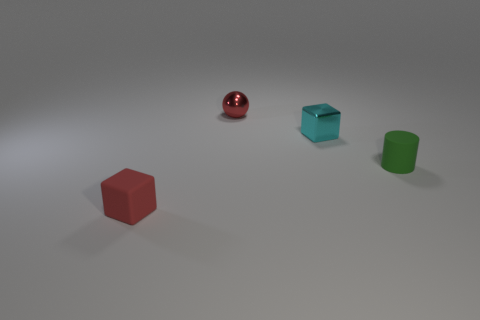Add 1 small red objects. How many objects exist? 5 Subtract all cyan cubes. How many cubes are left? 1 Subtract 1 balls. How many balls are left? 0 Subtract all spheres. How many objects are left? 3 Add 1 small red balls. How many small red balls are left? 2 Add 3 blue metallic blocks. How many blue metallic blocks exist? 3 Subtract 0 gray blocks. How many objects are left? 4 Subtract all brown cylinders. Subtract all gray cubes. How many cylinders are left? 1 Subtract all big red blocks. Subtract all tiny green rubber objects. How many objects are left? 3 